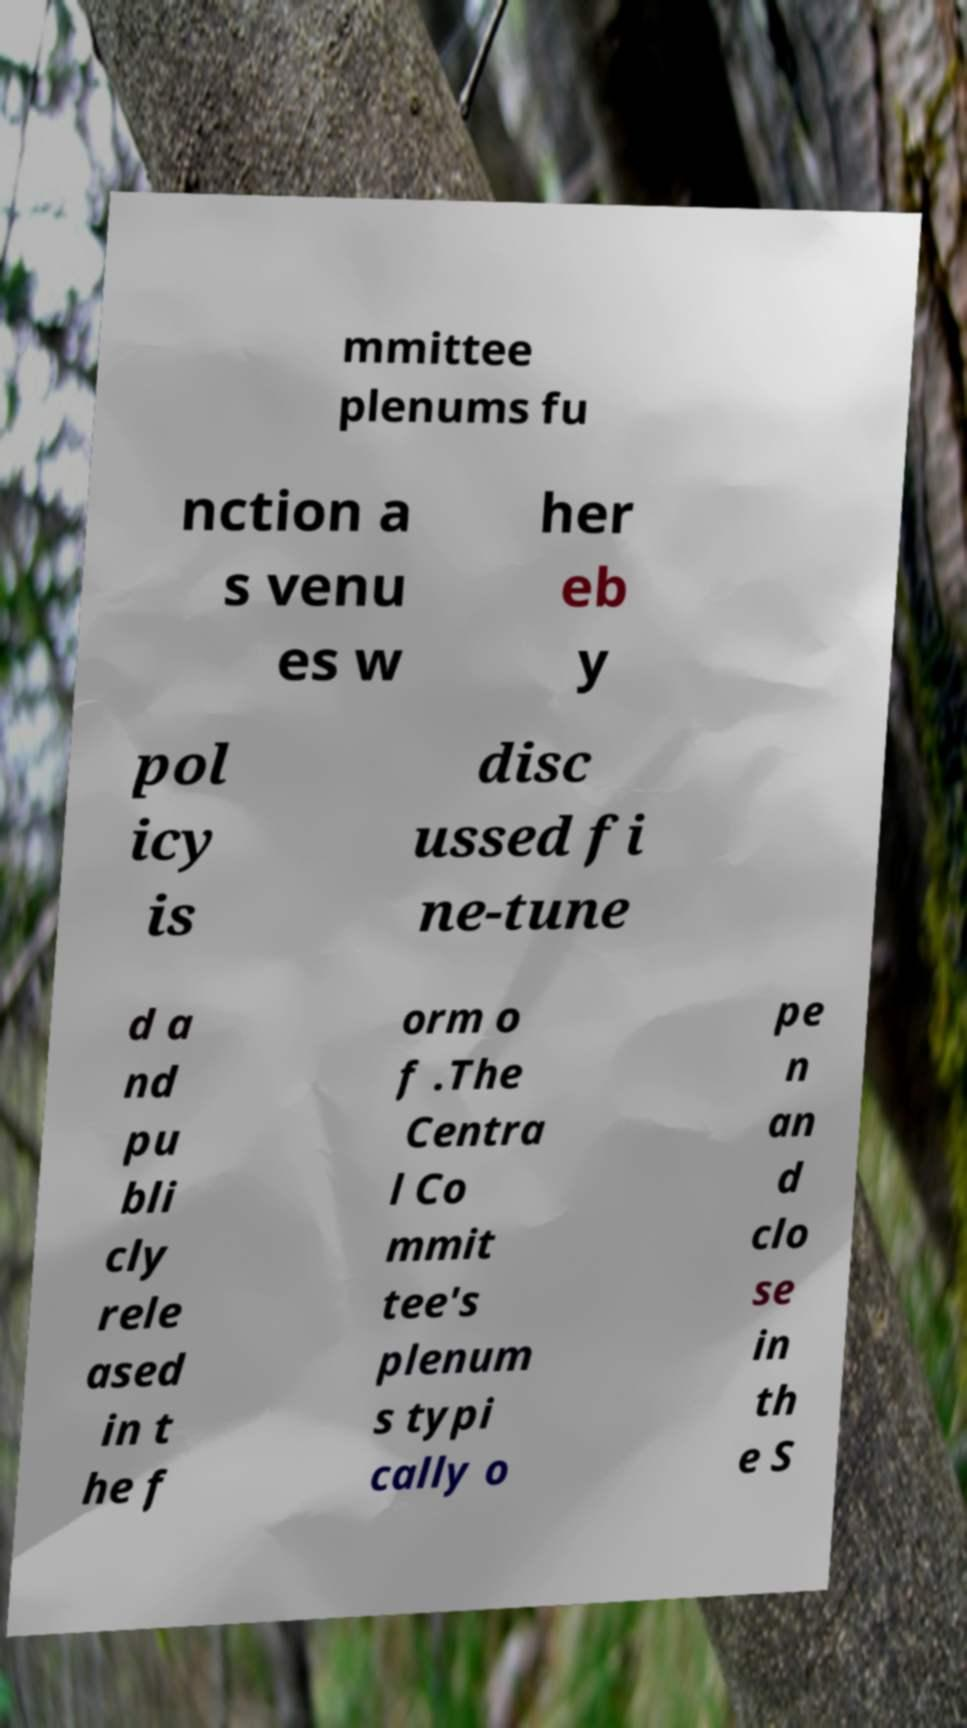Please identify and transcribe the text found in this image. mmittee plenums fu nction a s venu es w her eb y pol icy is disc ussed fi ne-tune d a nd pu bli cly rele ased in t he f orm o f .The Centra l Co mmit tee's plenum s typi cally o pe n an d clo se in th e S 